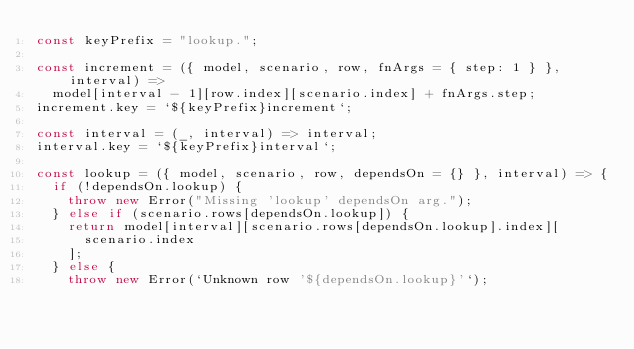Convert code to text. <code><loc_0><loc_0><loc_500><loc_500><_JavaScript_>const keyPrefix = "lookup.";

const increment = ({ model, scenario, row, fnArgs = { step: 1 } }, interval) =>
  model[interval - 1][row.index][scenario.index] + fnArgs.step;
increment.key = `${keyPrefix}increment`;

const interval = (_, interval) => interval;
interval.key = `${keyPrefix}interval`;

const lookup = ({ model, scenario, row, dependsOn = {} }, interval) => {
  if (!dependsOn.lookup) {
    throw new Error("Missing 'lookup' dependsOn arg.");
  } else if (scenario.rows[dependsOn.lookup]) {
    return model[interval][scenario.rows[dependsOn.lookup].index][
      scenario.index
    ];
  } else {
    throw new Error(`Unknown row '${dependsOn.lookup}'`);</code> 